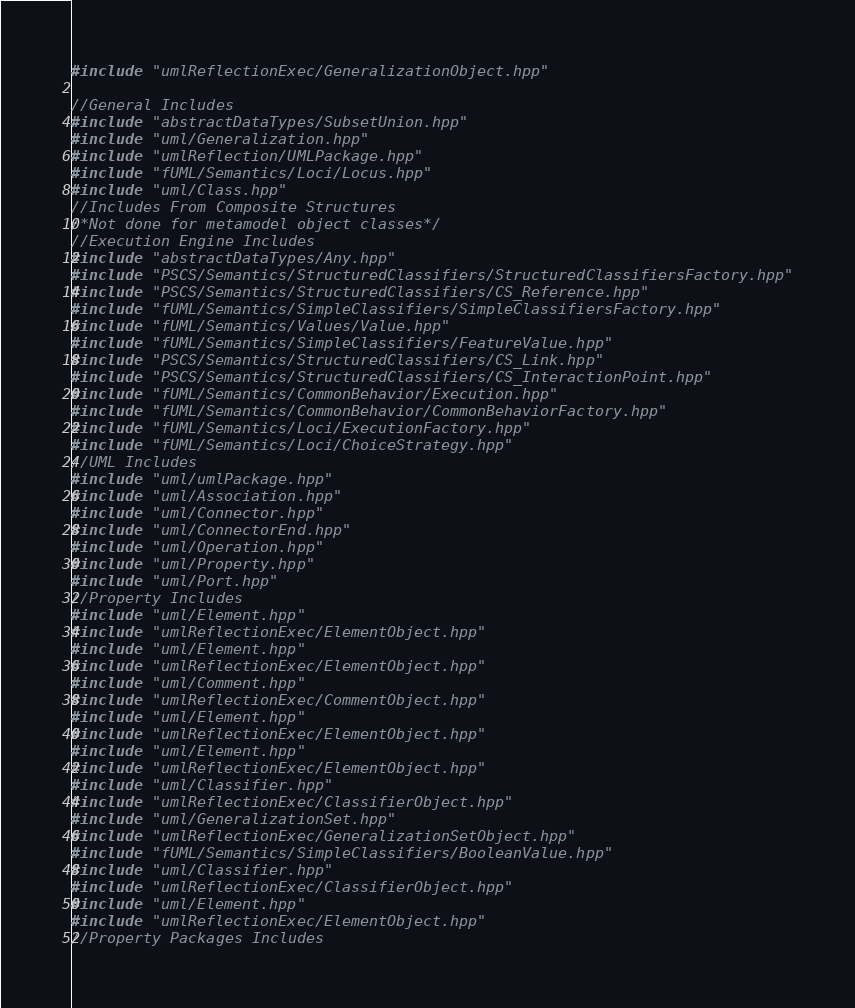Convert code to text. <code><loc_0><loc_0><loc_500><loc_500><_C++_>#include "umlReflectionExec/GeneralizationObject.hpp"

//General Includes
#include "abstractDataTypes/SubsetUnion.hpp"
#include "uml/Generalization.hpp"
#include "umlReflection/UMLPackage.hpp"
#include "fUML/Semantics/Loci/Locus.hpp"
#include "uml/Class.hpp"
//Includes From Composite Structures
/*Not done for metamodel object classes*/
//Execution Engine Includes
#include "abstractDataTypes/Any.hpp"
#include "PSCS/Semantics/StructuredClassifiers/StructuredClassifiersFactory.hpp"
#include "PSCS/Semantics/StructuredClassifiers/CS_Reference.hpp"
#include "fUML/Semantics/SimpleClassifiers/SimpleClassifiersFactory.hpp"
#include "fUML/Semantics/Values/Value.hpp"
#include "fUML/Semantics/SimpleClassifiers/FeatureValue.hpp"
#include "PSCS/Semantics/StructuredClassifiers/CS_Link.hpp"
#include "PSCS/Semantics/StructuredClassifiers/CS_InteractionPoint.hpp"
#include "fUML/Semantics/CommonBehavior/Execution.hpp"
#include "fUML/Semantics/CommonBehavior/CommonBehaviorFactory.hpp"
#include "fUML/Semantics/Loci/ExecutionFactory.hpp"
#include "fUML/Semantics/Loci/ChoiceStrategy.hpp"
//UML Includes
#include "uml/umlPackage.hpp"
#include "uml/Association.hpp"
#include "uml/Connector.hpp"
#include "uml/ConnectorEnd.hpp"
#include "uml/Operation.hpp"
#include "uml/Property.hpp"
#include "uml/Port.hpp"
//Property Includes
#include "uml/Element.hpp"
#include "umlReflectionExec/ElementObject.hpp"
#include "uml/Element.hpp"
#include "umlReflectionExec/ElementObject.hpp"
#include "uml/Comment.hpp"
#include "umlReflectionExec/CommentObject.hpp"
#include "uml/Element.hpp"
#include "umlReflectionExec/ElementObject.hpp"
#include "uml/Element.hpp"
#include "umlReflectionExec/ElementObject.hpp"
#include "uml/Classifier.hpp"
#include "umlReflectionExec/ClassifierObject.hpp"
#include "uml/GeneralizationSet.hpp"
#include "umlReflectionExec/GeneralizationSetObject.hpp"
#include "fUML/Semantics/SimpleClassifiers/BooleanValue.hpp"
#include "uml/Classifier.hpp"
#include "umlReflectionExec/ClassifierObject.hpp"
#include "uml/Element.hpp"
#include "umlReflectionExec/ElementObject.hpp"
//Property Packages Includes</code> 